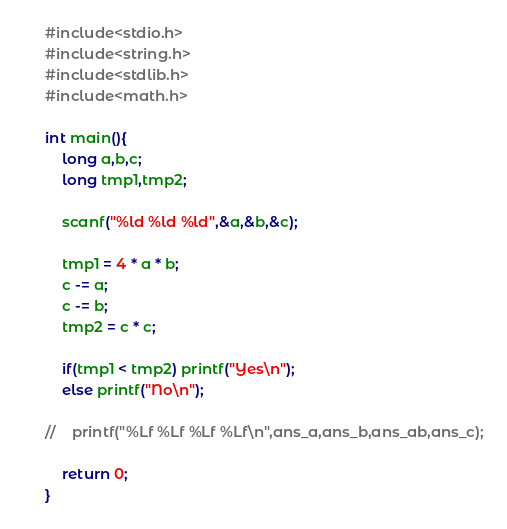<code> <loc_0><loc_0><loc_500><loc_500><_C_>#include<stdio.h>
#include<string.h>
#include<stdlib.h>
#include<math.h>

int main(){
    long a,b,c;
    long tmp1,tmp2;
    
    scanf("%ld %ld %ld",&a,&b,&c);
    
    tmp1 = 4 * a * b;
    c -= a;
    c -= b;
    tmp2 = c * c;
    
    if(tmp1 < tmp2) printf("Yes\n");
    else printf("No\n");
    
//    printf("%Lf %Lf %Lf %Lf\n",ans_a,ans_b,ans_ab,ans_c);
    
    return 0;
}
</code> 